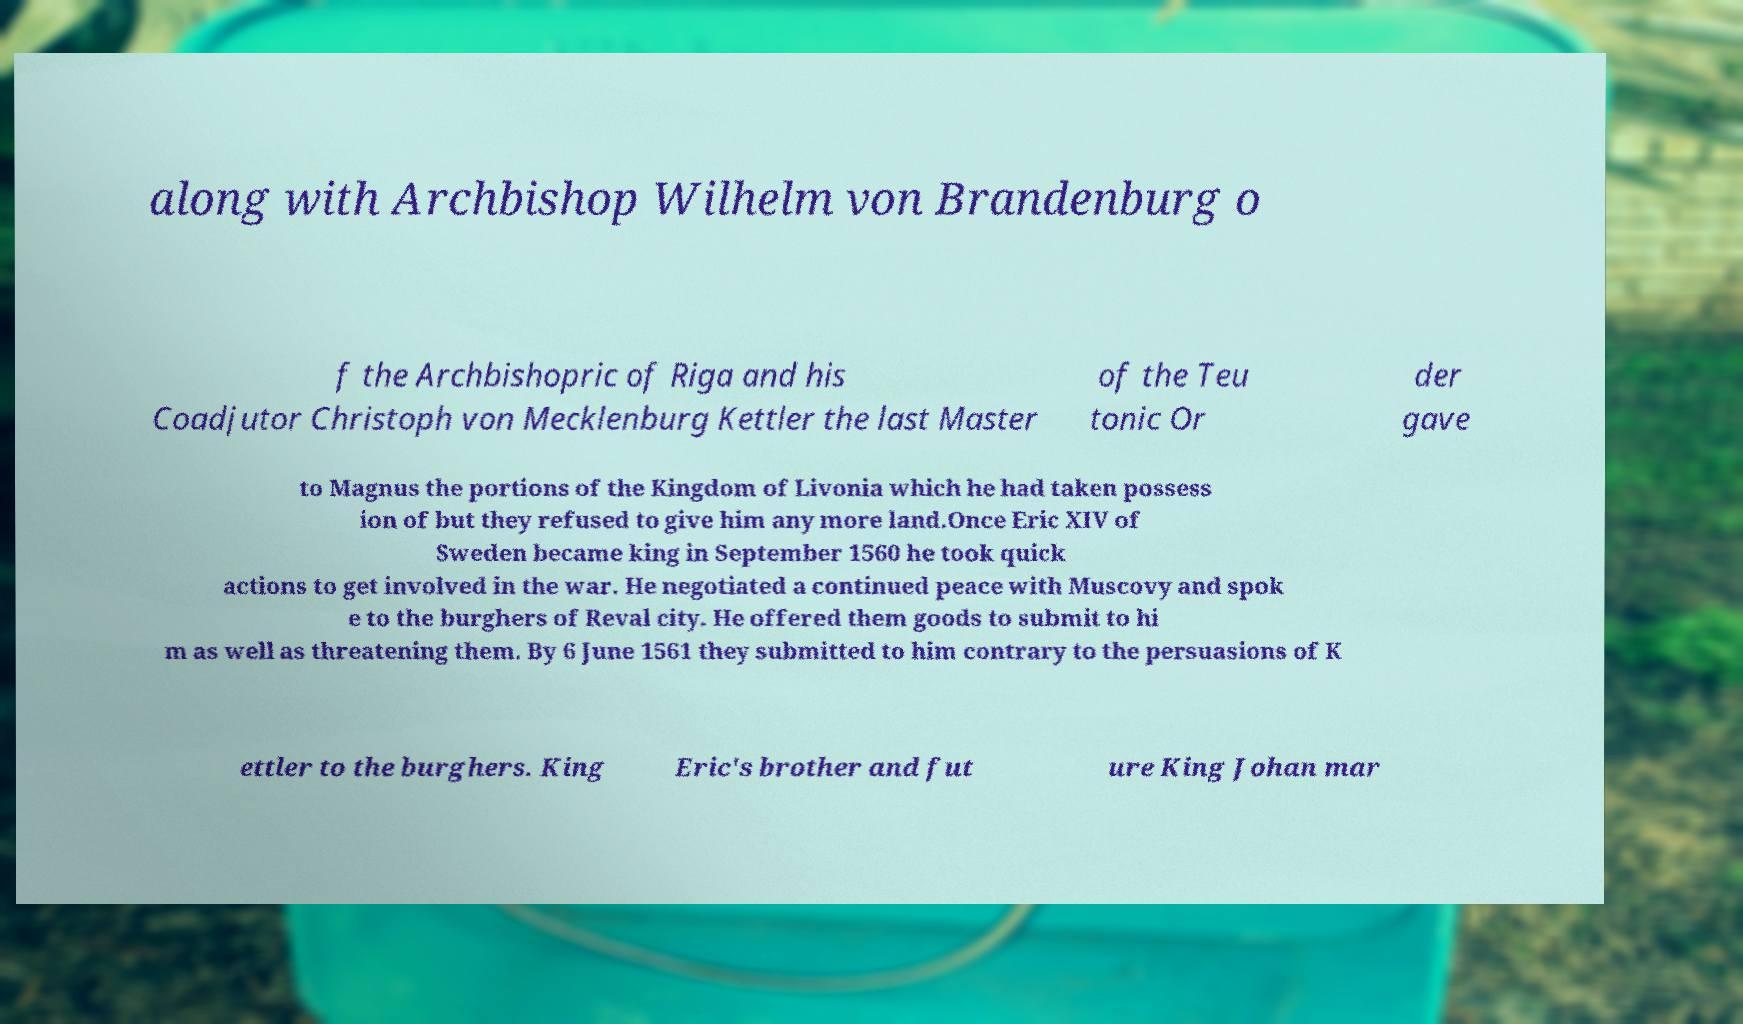Could you extract and type out the text from this image? along with Archbishop Wilhelm von Brandenburg o f the Archbishopric of Riga and his Coadjutor Christoph von Mecklenburg Kettler the last Master of the Teu tonic Or der gave to Magnus the portions of the Kingdom of Livonia which he had taken possess ion of but they refused to give him any more land.Once Eric XIV of Sweden became king in September 1560 he took quick actions to get involved in the war. He negotiated a continued peace with Muscovy and spok e to the burghers of Reval city. He offered them goods to submit to hi m as well as threatening them. By 6 June 1561 they submitted to him contrary to the persuasions of K ettler to the burghers. King Eric's brother and fut ure King Johan mar 